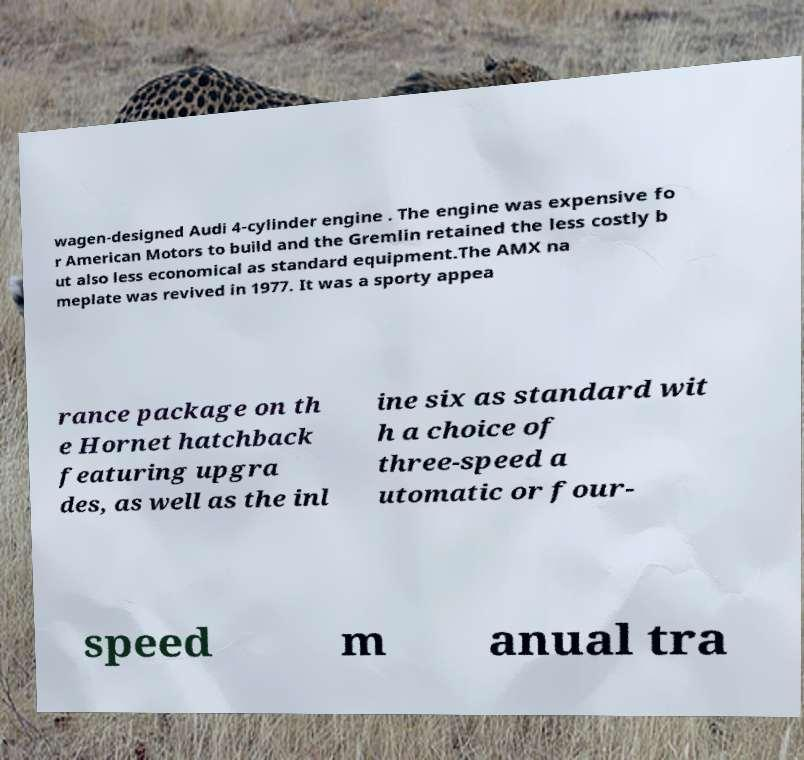Could you assist in decoding the text presented in this image and type it out clearly? wagen-designed Audi 4-cylinder engine . The engine was expensive fo r American Motors to build and the Gremlin retained the less costly b ut also less economical as standard equipment.The AMX na meplate was revived in 1977. It was a sporty appea rance package on th e Hornet hatchback featuring upgra des, as well as the inl ine six as standard wit h a choice of three-speed a utomatic or four- speed m anual tra 